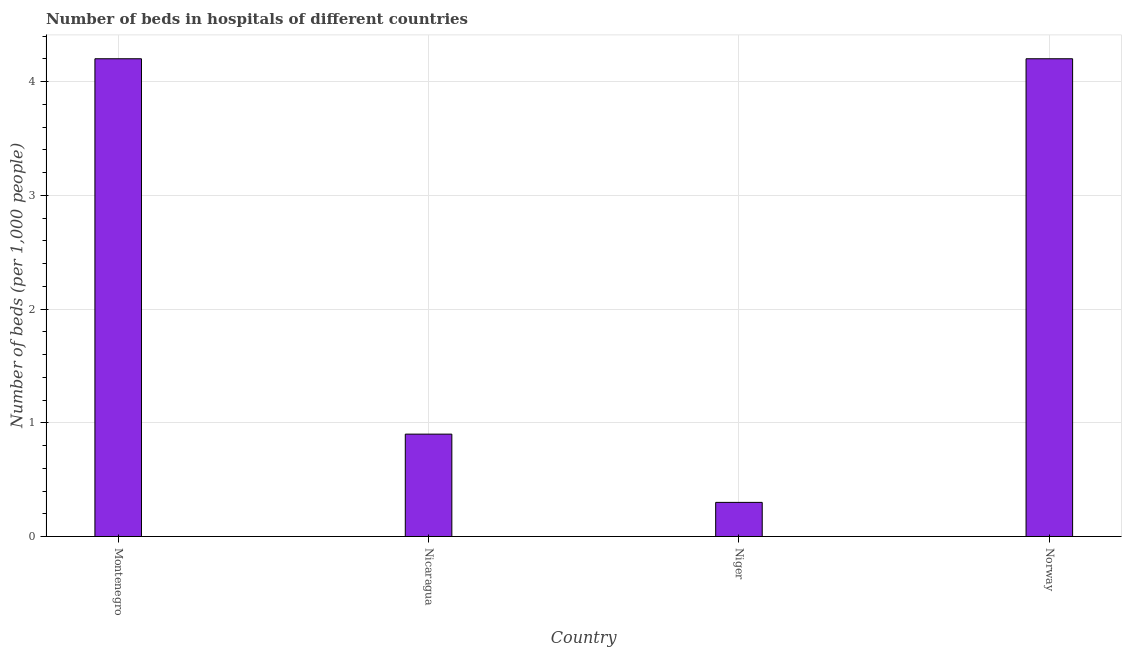Does the graph contain any zero values?
Provide a short and direct response. No. Does the graph contain grids?
Offer a terse response. Yes. What is the title of the graph?
Offer a terse response. Number of beds in hospitals of different countries. What is the label or title of the X-axis?
Ensure brevity in your answer.  Country. What is the label or title of the Y-axis?
Make the answer very short. Number of beds (per 1,0 people). What is the number of hospital beds in Nicaragua?
Your answer should be compact. 0.9. Across all countries, what is the maximum number of hospital beds?
Provide a succinct answer. 4.2. Across all countries, what is the minimum number of hospital beds?
Offer a very short reply. 0.3. In which country was the number of hospital beds maximum?
Ensure brevity in your answer.  Montenegro. In which country was the number of hospital beds minimum?
Provide a short and direct response. Niger. What is the sum of the number of hospital beds?
Offer a terse response. 9.6. What is the average number of hospital beds per country?
Keep it short and to the point. 2.4. What is the median number of hospital beds?
Keep it short and to the point. 2.55. In how many countries, is the number of hospital beds greater than 3.2 %?
Ensure brevity in your answer.  2. What is the ratio of the number of hospital beds in Montenegro to that in Niger?
Provide a succinct answer. 14. Is the number of hospital beds in Nicaragua less than that in Norway?
Provide a succinct answer. Yes. What is the difference between the highest and the second highest number of hospital beds?
Your answer should be very brief. 0. What is the difference between the highest and the lowest number of hospital beds?
Your answer should be compact. 3.9. In how many countries, is the number of hospital beds greater than the average number of hospital beds taken over all countries?
Give a very brief answer. 2. How many bars are there?
Make the answer very short. 4. How many countries are there in the graph?
Make the answer very short. 4. What is the difference between two consecutive major ticks on the Y-axis?
Offer a terse response. 1. Are the values on the major ticks of Y-axis written in scientific E-notation?
Your response must be concise. No. What is the Number of beds (per 1,000 people) of Montenegro?
Provide a short and direct response. 4.2. What is the Number of beds (per 1,000 people) of Nicaragua?
Your answer should be compact. 0.9. What is the difference between the Number of beds (per 1,000 people) in Montenegro and Nicaragua?
Your answer should be compact. 3.3. What is the difference between the Number of beds (per 1,000 people) in Montenegro and Niger?
Give a very brief answer. 3.9. What is the difference between the Number of beds (per 1,000 people) in Montenegro and Norway?
Make the answer very short. 0. What is the difference between the Number of beds (per 1,000 people) in Nicaragua and Niger?
Provide a succinct answer. 0.6. What is the difference between the Number of beds (per 1,000 people) in Niger and Norway?
Provide a succinct answer. -3.9. What is the ratio of the Number of beds (per 1,000 people) in Montenegro to that in Nicaragua?
Provide a short and direct response. 4.67. What is the ratio of the Number of beds (per 1,000 people) in Montenegro to that in Niger?
Ensure brevity in your answer.  14. What is the ratio of the Number of beds (per 1,000 people) in Nicaragua to that in Norway?
Ensure brevity in your answer.  0.21. What is the ratio of the Number of beds (per 1,000 people) in Niger to that in Norway?
Offer a very short reply. 0.07. 